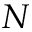Convert formula to latex. <formula><loc_0><loc_0><loc_500><loc_500>N</formula> 